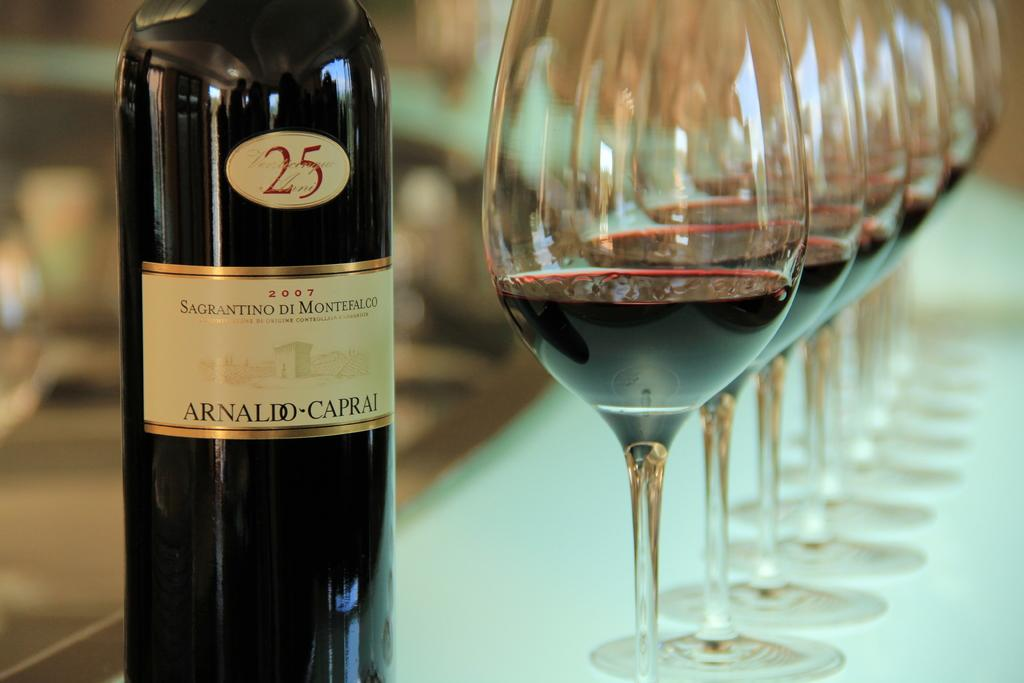<image>
Provide a brief description of the given image. A bottle of 2007 Sagrantino Di Montefalco wine next to filled wine glasses. 